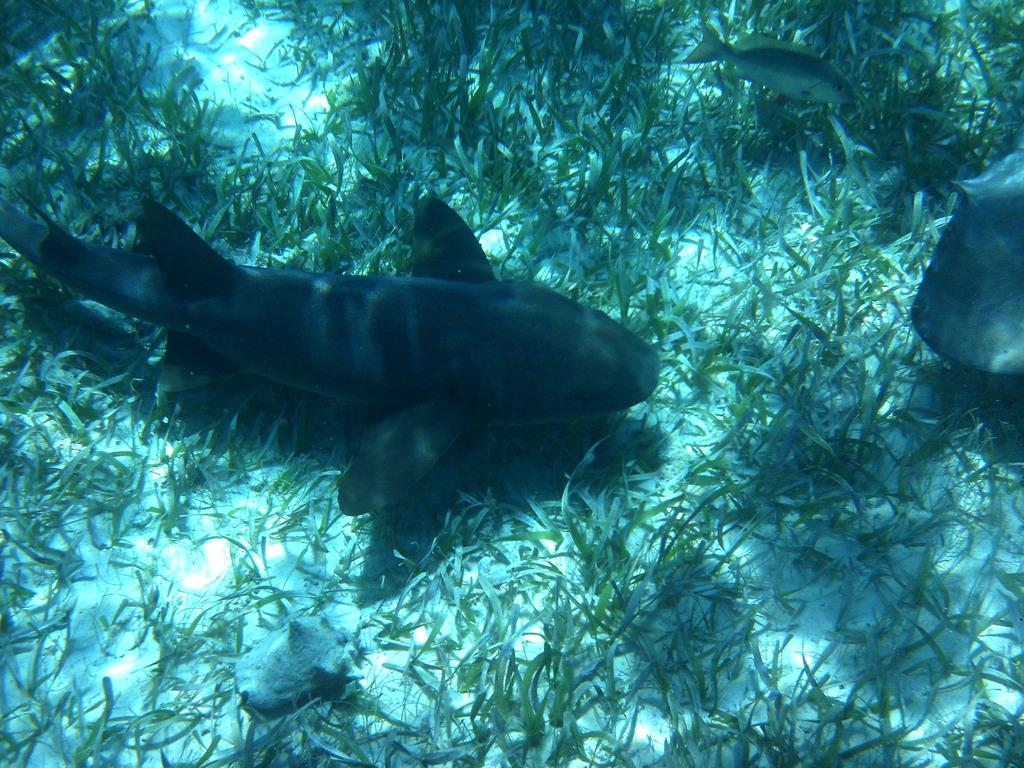What type of animals can be seen in the image? There are aquatic animals in the image. What is unusual about the sea surface in the image? There is grass on the sea surface in the image. What type of poison can be seen on the desk in the image? There is no desk or poison present in the image; it features aquatic animals and grass on the sea surface. 